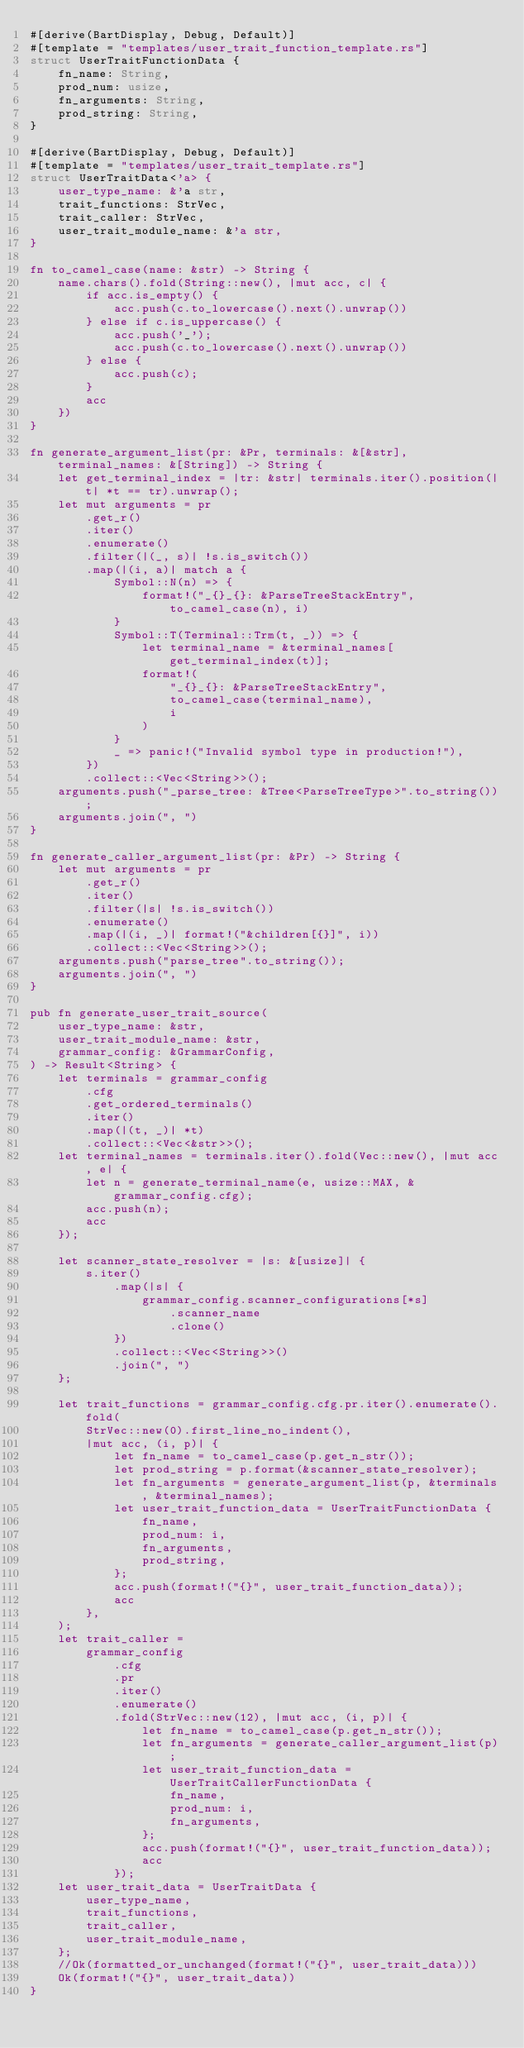<code> <loc_0><loc_0><loc_500><loc_500><_Rust_>#[derive(BartDisplay, Debug, Default)]
#[template = "templates/user_trait_function_template.rs"]
struct UserTraitFunctionData {
    fn_name: String,
    prod_num: usize,
    fn_arguments: String,
    prod_string: String,
}

#[derive(BartDisplay, Debug, Default)]
#[template = "templates/user_trait_template.rs"]
struct UserTraitData<'a> {
    user_type_name: &'a str,
    trait_functions: StrVec,
    trait_caller: StrVec,
    user_trait_module_name: &'a str,
}

fn to_camel_case(name: &str) -> String {
    name.chars().fold(String::new(), |mut acc, c| {
        if acc.is_empty() {
            acc.push(c.to_lowercase().next().unwrap())
        } else if c.is_uppercase() {
            acc.push('_');
            acc.push(c.to_lowercase().next().unwrap())
        } else {
            acc.push(c);
        }
        acc
    })
}

fn generate_argument_list(pr: &Pr, terminals: &[&str], terminal_names: &[String]) -> String {
    let get_terminal_index = |tr: &str| terminals.iter().position(|t| *t == tr).unwrap();
    let mut arguments = pr
        .get_r()
        .iter()
        .enumerate()
        .filter(|(_, s)| !s.is_switch())
        .map(|(i, a)| match a {
            Symbol::N(n) => {
                format!("_{}_{}: &ParseTreeStackEntry", to_camel_case(n), i)
            }
            Symbol::T(Terminal::Trm(t, _)) => {
                let terminal_name = &terminal_names[get_terminal_index(t)];
                format!(
                    "_{}_{}: &ParseTreeStackEntry",
                    to_camel_case(terminal_name),
                    i
                )
            }
            _ => panic!("Invalid symbol type in production!"),
        })
        .collect::<Vec<String>>();
    arguments.push("_parse_tree: &Tree<ParseTreeType>".to_string());
    arguments.join(", ")
}

fn generate_caller_argument_list(pr: &Pr) -> String {
    let mut arguments = pr
        .get_r()
        .iter()
        .filter(|s| !s.is_switch())
        .enumerate()
        .map(|(i, _)| format!("&children[{}]", i))
        .collect::<Vec<String>>();
    arguments.push("parse_tree".to_string());
    arguments.join(", ")
}

pub fn generate_user_trait_source(
    user_type_name: &str,
    user_trait_module_name: &str,
    grammar_config: &GrammarConfig,
) -> Result<String> {
    let terminals = grammar_config
        .cfg
        .get_ordered_terminals()
        .iter()
        .map(|(t, _)| *t)
        .collect::<Vec<&str>>();
    let terminal_names = terminals.iter().fold(Vec::new(), |mut acc, e| {
        let n = generate_terminal_name(e, usize::MAX, &grammar_config.cfg);
        acc.push(n);
        acc
    });

    let scanner_state_resolver = |s: &[usize]| {
        s.iter()
            .map(|s| {
                grammar_config.scanner_configurations[*s]
                    .scanner_name
                    .clone()
            })
            .collect::<Vec<String>>()
            .join(", ")
    };

    let trait_functions = grammar_config.cfg.pr.iter().enumerate().fold(
        StrVec::new(0).first_line_no_indent(),
        |mut acc, (i, p)| {
            let fn_name = to_camel_case(p.get_n_str());
            let prod_string = p.format(&scanner_state_resolver);
            let fn_arguments = generate_argument_list(p, &terminals, &terminal_names);
            let user_trait_function_data = UserTraitFunctionData {
                fn_name,
                prod_num: i,
                fn_arguments,
                prod_string,
            };
            acc.push(format!("{}", user_trait_function_data));
            acc
        },
    );
    let trait_caller =
        grammar_config
            .cfg
            .pr
            .iter()
            .enumerate()
            .fold(StrVec::new(12), |mut acc, (i, p)| {
                let fn_name = to_camel_case(p.get_n_str());
                let fn_arguments = generate_caller_argument_list(p);
                let user_trait_function_data = UserTraitCallerFunctionData {
                    fn_name,
                    prod_num: i,
                    fn_arguments,
                };
                acc.push(format!("{}", user_trait_function_data));
                acc
            });
    let user_trait_data = UserTraitData {
        user_type_name,
        trait_functions,
        trait_caller,
        user_trait_module_name,
    };
    //Ok(formatted_or_unchanged(format!("{}", user_trait_data)))
    Ok(format!("{}", user_trait_data))
}
</code> 